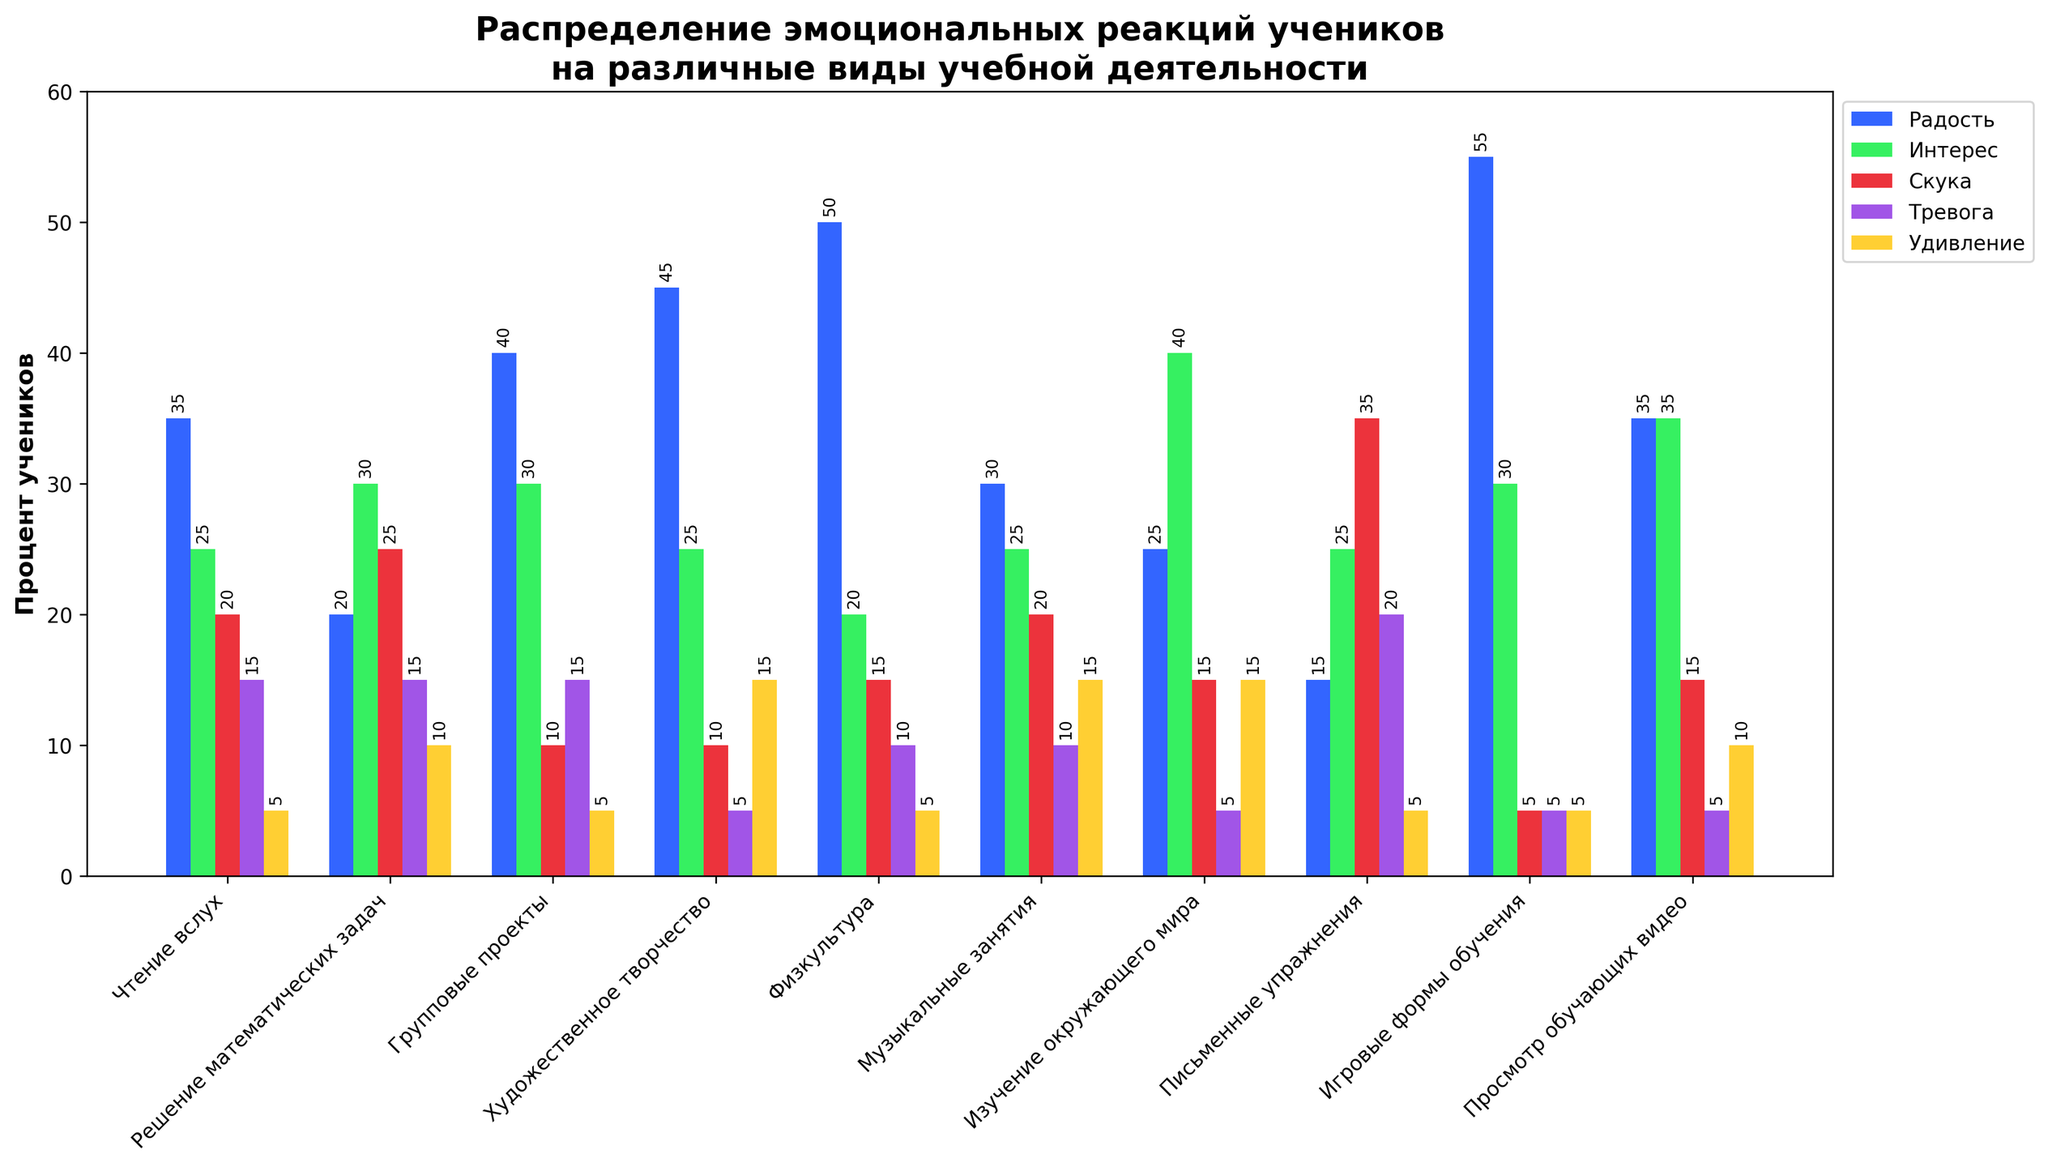Какая учебная деятельность вызывает наибольшее количество радости у учеников? Сравните высоту столбиков радости для всех видов деятельности и найдите самый высокий. Столбик для "Игровые формы обучения" самый высокий и соответствует 55%.
Answer: Игровые формы обучения Какое значение интереса выше: при чтении вслух или при решении математических задач? Найдите столбики, соответствующие интересу для "Чтение вслух" и "Решение математических задач". Столбик "Решение математических задач" выше и соответствует 30%, а у "Чтение вслух" - 25%.
Answer: Решение математических задач Чему равно общее количество учеников, проявляющих скуку во всех видах деятельности? Сложите значения скуки для каждого вида деятельности: 20 + 25 + 10 + 10 + 15 + 20 + 15 + 35 + 5 + 15 = 170.
Answer: 170 Что вызывает у учеников больше тревоги: групповая работа или физкультура? Найдите столбики тревоги для "Групповые проекты" и "Физкультура". У "Групповых проектов" и "Физкультуры" значения одинаковые, по 15%.
Answer: равно Какая учебная деятельность вызывает самое меньшее количество удивления? Сравните столбики удивления для всех видов деятельности и найдите самый низкий. Самый низкий столбик у "Чтение вслух" и "Игровые формы обучения", оба по 5%.
Answer: Чтение вслух и Игровые формы обучения Какой процент учеников испытывает радость при художественном творчестве и удивление при физкультуре вместе? Найдите значения радости для "Художественное творчество" и удивления для "Физкультура". Сложите эти значения: 45 + 5 = 50.
Answer: 50 На какие виды деятельности меньше всего реагируют тревогой и скукой вместе? Сложите значения тревоги и скуки для всех видов деятельности и найдите наименьшую сумму. "Игровые формы обучения": 5 (тревога) + 5 (скука) = 10.
Answer: Игровые формы обучения Чему равен средний процент интереса учеников в музыкальных занятиях и изучении окружающего мира? Найдите значения интереса для "Музыкальные занятия" и "Изучение окружающего мира". Сложите эти значения и разделите на 2: (25 + 40) / 2 = 32.5.
Answer: 32.5 Какая учебная деятельность вызывает больше скуки: письменные упражнения или чтение вслух? Найдите значения скуки для "Письменные упражнения" и "Чтение вслух". У "Письменные упражнения" значение 35%, что больше, чем у "Чтение вслух" с 20%.
Answer: Письменные упражнения В какой учебной деятельности наблюдается наибольшее количество эмоций (сумма всех эмоциональных реакций)? Сложите все значения эмоций для каждого вида деятельности и найдите максимальную сумму. "Игровые формы обучения" имеет наибольшую сумму (55 + 30 + 5 + 5 + 5 = 100).
Answer: Игровые формы обучения 